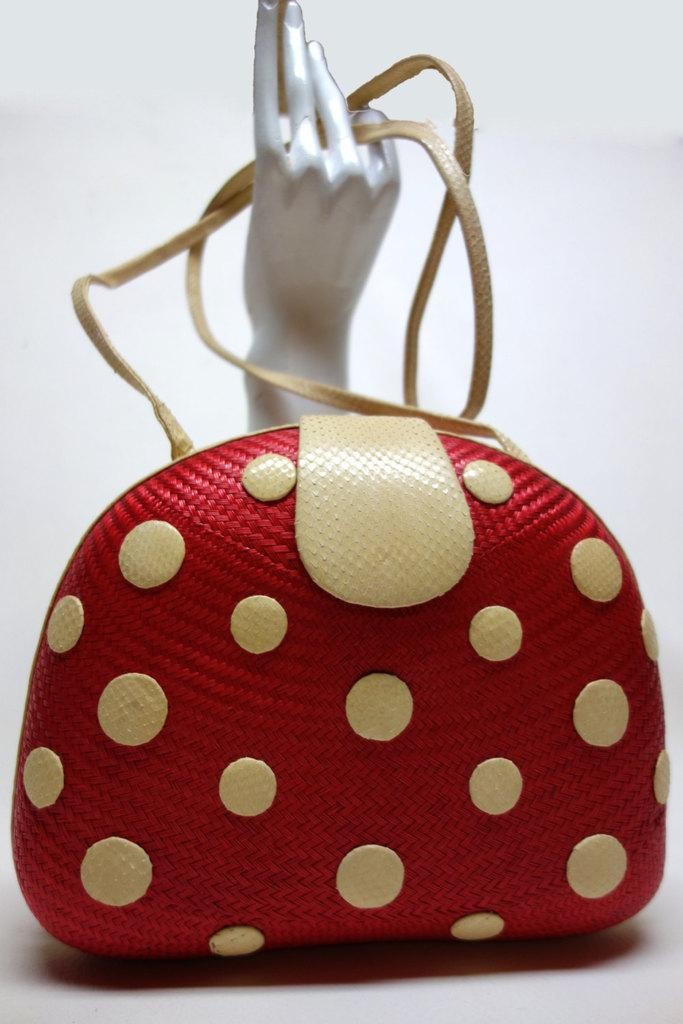What object can be seen in the image? There is a bag in the image. What colors are present on the bag? The bag has red and white colors. What is the material of the hand behind the bag? The hand behind the bag appears to be metallic. What color is the background of the image? The background of the image is white. What is the name of the sheep in the image? There are no sheep present in the image; it only features a bag and a metallic hand. 